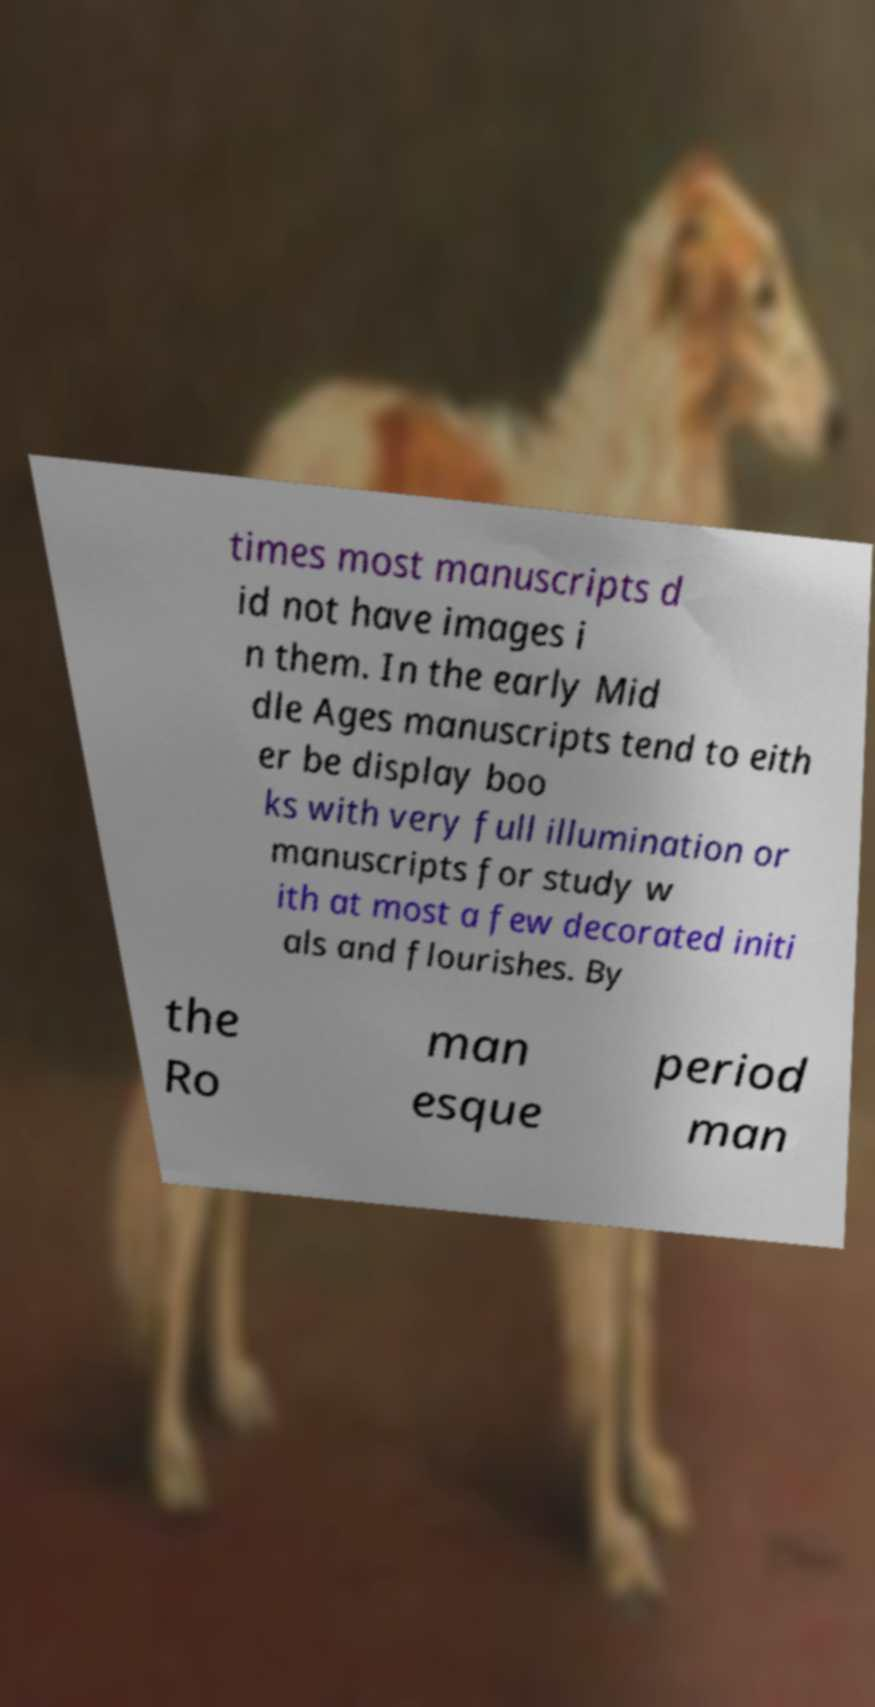Please read and relay the text visible in this image. What does it say? times most manuscripts d id not have images i n them. In the early Mid dle Ages manuscripts tend to eith er be display boo ks with very full illumination or manuscripts for study w ith at most a few decorated initi als and flourishes. By the Ro man esque period man 